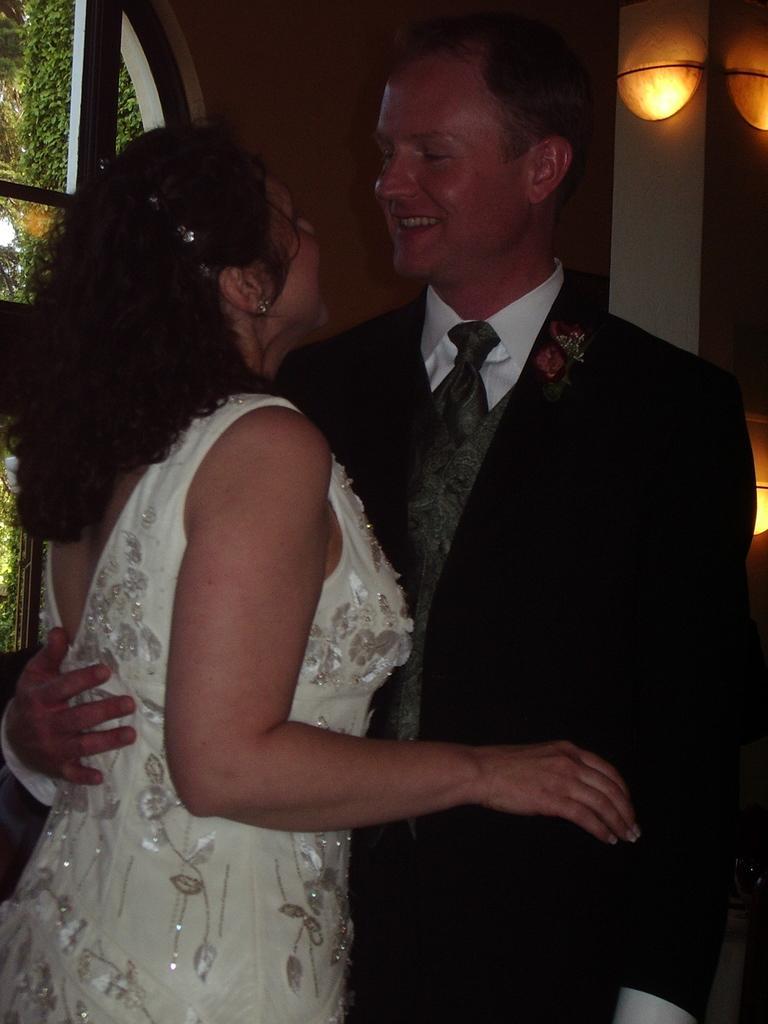How would you summarize this image in a sentence or two? In this image I can see a woman wearing white colored dress and a person wearing black and white colored dress are standing. In the background I can see the wall, few lights and the window through which I can see few trees. 